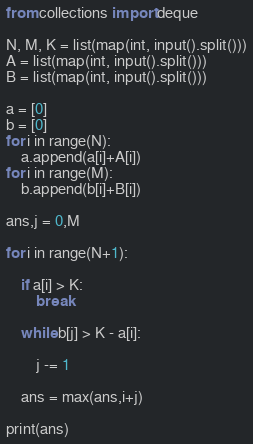Convert code to text. <code><loc_0><loc_0><loc_500><loc_500><_Python_>from collections import deque

N, M, K = list(map(int, input().split()))
A = list(map(int, input().split()))
B = list(map(int, input().split()))

a = [0]
b = [0]
for i in range(N):
    a.append(a[i]+A[i])
for i in range(M):
    b.append(b[i]+B[i])

ans,j = 0,M

for i in range(N+1):
    
    if a[i] > K:
        break
    
    while b[j] > K - a[i]:
    
        j -= 1
    
    ans = max(ans,i+j)

print(ans)
</code> 